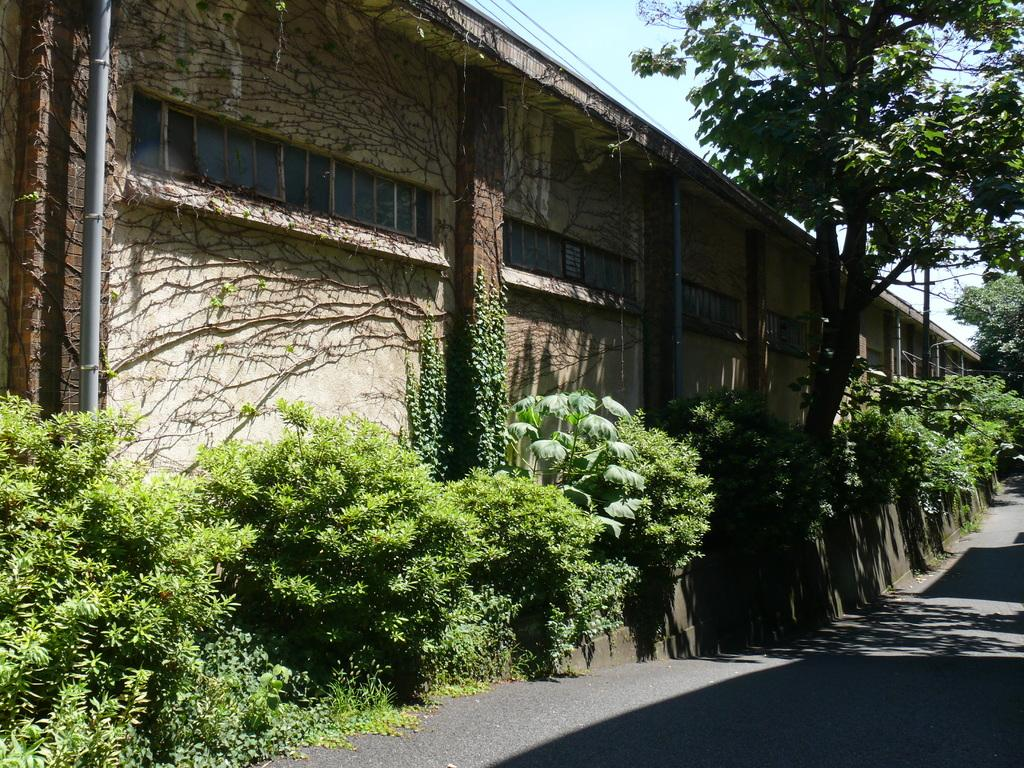What type of vegetation can be seen in the image? There are plants and trees in the image. What structures are present in the image? There is a pole and a building in the image. Can you describe any man-made objects in the image? There is a pipe on the wall in the image. What route does the scale take through the image? There is no scale present in the image, so it cannot take a route through the image. 